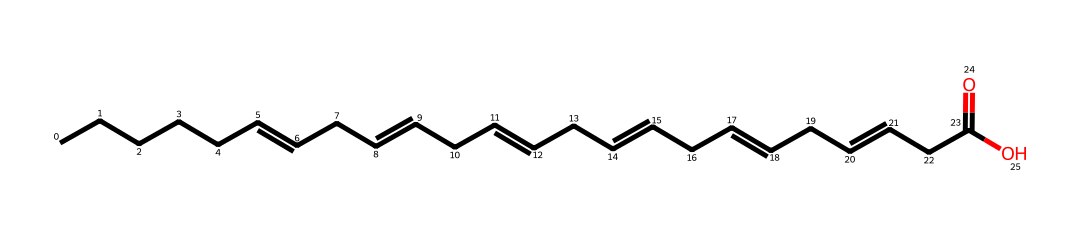What type of lipid is represented by this structure? The chemical structure provided contains multiple double bonds and a long hydrocarbon chain, characteristic of polyunsaturated fatty acids, which are a type of lipid.
Answer: polyunsaturated fatty acid How many double bonds are present in this structure? By analyzing the SMILES representation, we can identify three '=' signs, which indicate the presence of three double bonds in the fatty acid chain.
Answer: three What is the molecular functional group present at the end of this fatty acid? The chemical structure ends with "C(=O)O," indicating the presence of a carboxylic acid functional group (as it has a carbonyl (C=O) and an -OH group).
Answer: carboxylic acid What is the total number of carbon atoms in this fatty acid? Counting the carbon symbols from the SMILES and the total hydrogens associated with the carbon skeleton leads to the conclusion that there are eighteen carbon atoms in the fatty acid chain.
Answer: eighteen What property makes omega-3 fatty acids beneficial for health? The multiple double bonds and specific geometric configurations (cis) in omega-3 fatty acids are known to contribute to their health benefits, including anti-inflammatory properties.
Answer: anti-inflammatory How does this fatty acid differ from saturated fatty acids? Compared to saturated fatty acids, which have no double bonds, this structure clearly has multiple double bonds, indicating it is unsaturated, a key distinction.
Answer: unsaturated 